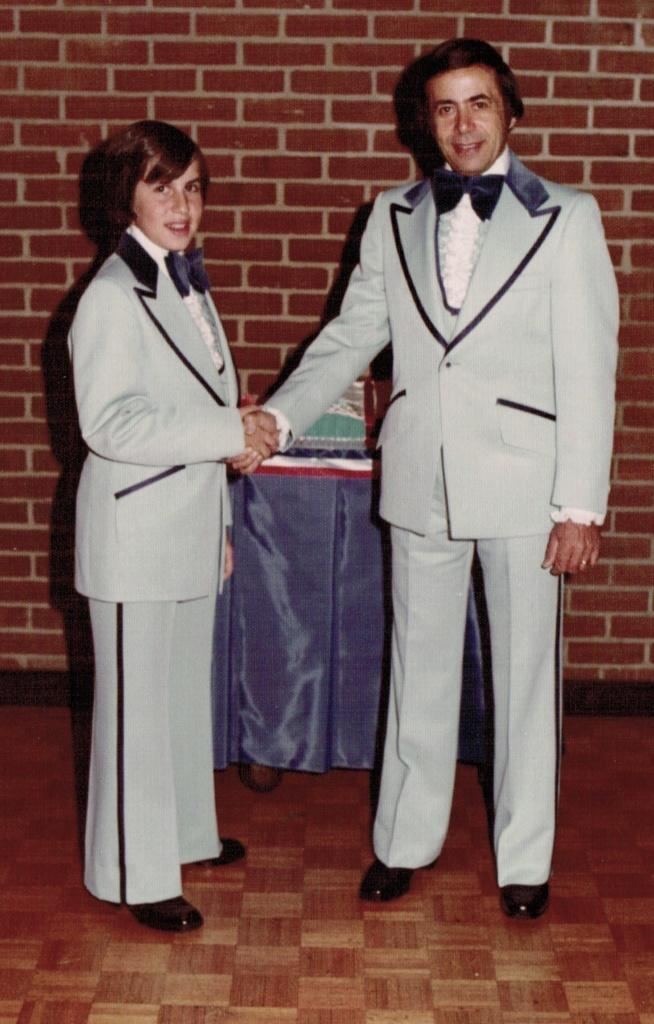How many people are in the image? There are two people in the image. What are the two people doing? The two people are shaking hands. What expression do the people have on their faces? Both people have a smile on their face. What can be seen in the background of the image? There is an object on a table in the background, and there is a wall behind the table. What type of coat is being worn by the person on the left in the image? There is no coat visible in the image; both people are wearing shirts. What type of base is supporting the table in the image? The image does not show the base of the table, so it cannot be determined from the image. 